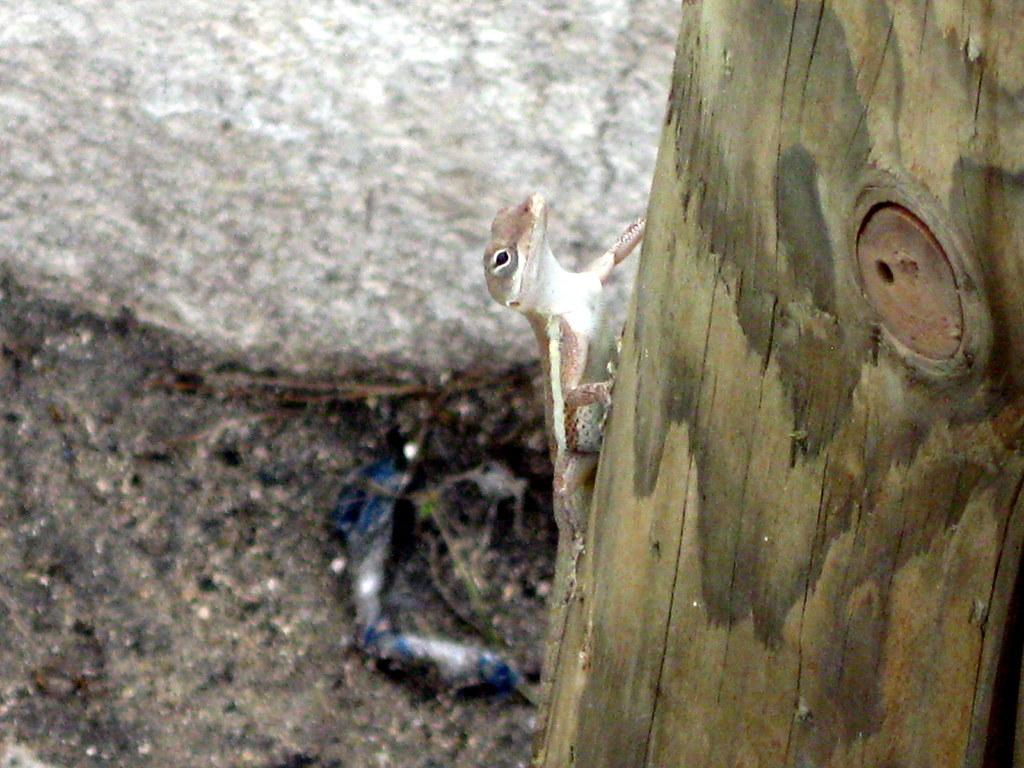What type of animal is in the image? There is a lizard in the image. What colors can be seen on the lizard? The lizard is in white and cream color. What is the lizard resting on in the image? The lizard is on a wooden object. What can be seen in the background of the image? There is a large stone in the background of the image. What type of surface is visible in the image? There is a ground visible in the image. What type of fowl can be seen flying over the lizard in the image? There is no fowl present in the image; it only features a lizard on a wooden object. Is the image taken during the night or day? The image does not provide any information about the time of day, so it cannot be determined whether it is night or day. 